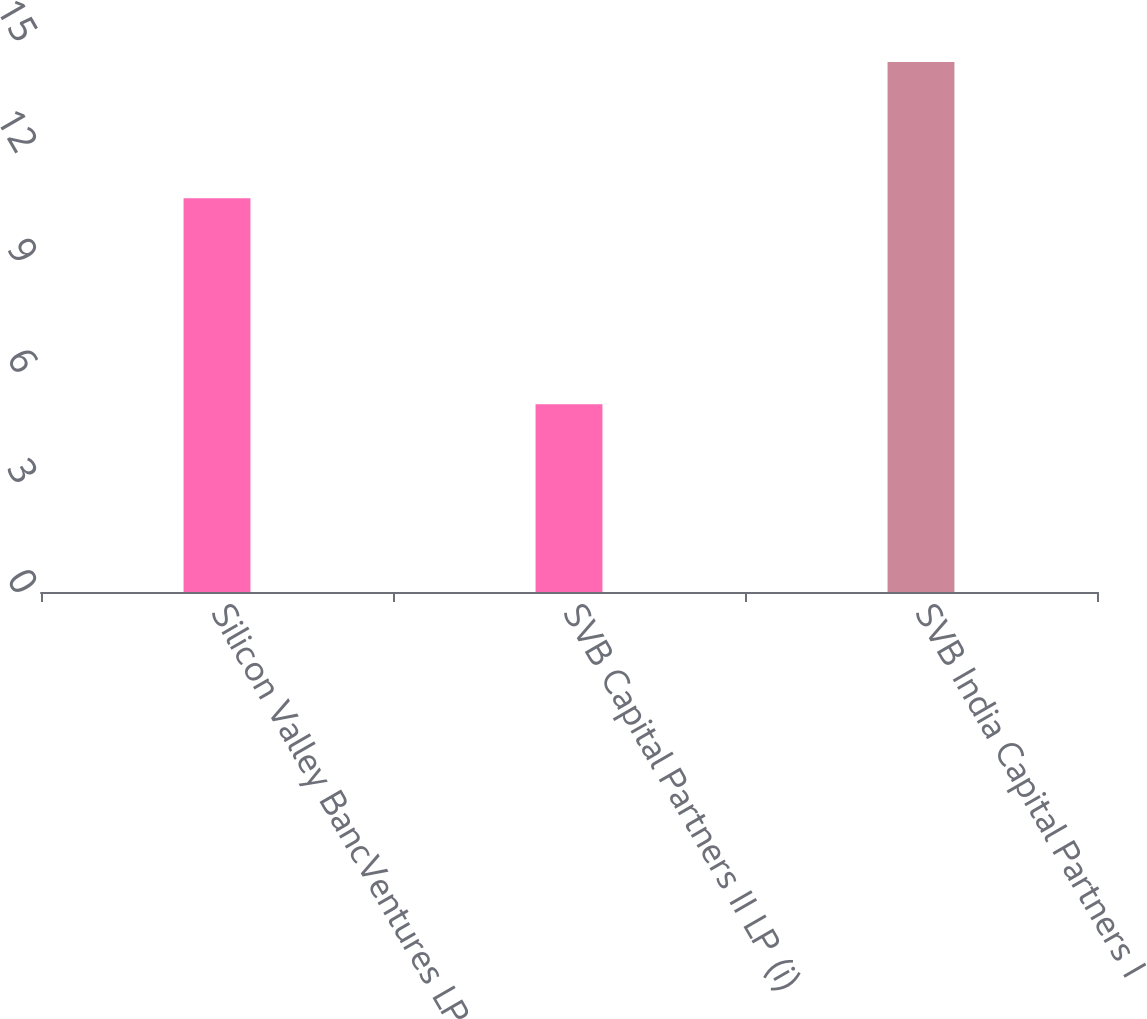Convert chart. <chart><loc_0><loc_0><loc_500><loc_500><bar_chart><fcel>Silicon Valley BancVentures LP<fcel>SVB Capital Partners II LP (i)<fcel>SVB India Capital Partners I<nl><fcel>10.7<fcel>5.1<fcel>14.4<nl></chart> 